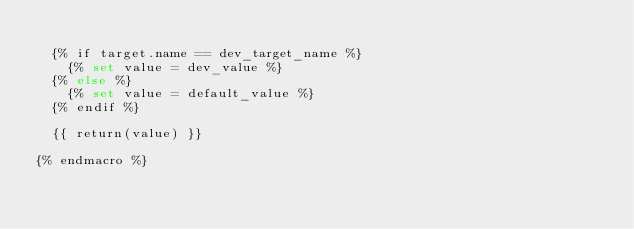<code> <loc_0><loc_0><loc_500><loc_500><_SQL_>
  {% if target.name == dev_target_name %}
    {% set value = dev_value %}
  {% else %}
    {% set value = default_value %}
  {% endif %}

  {{ return(value) }}

{% endmacro %}
</code> 